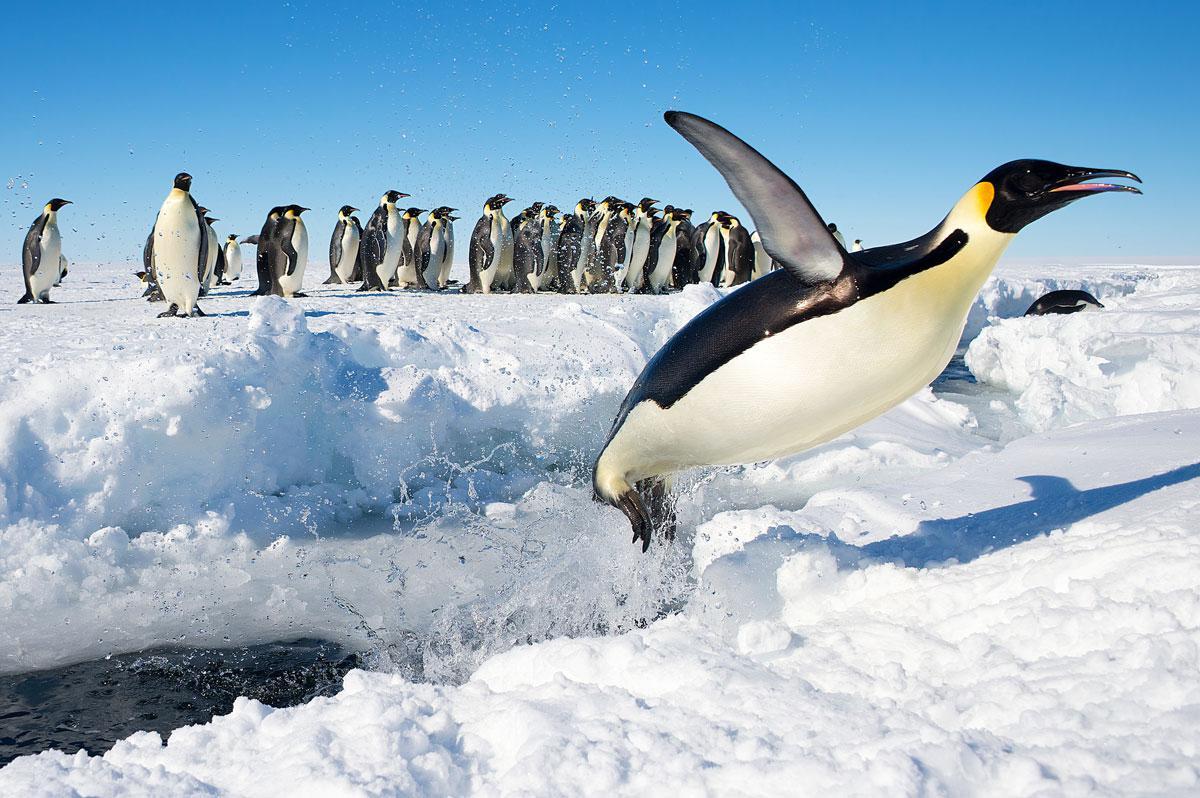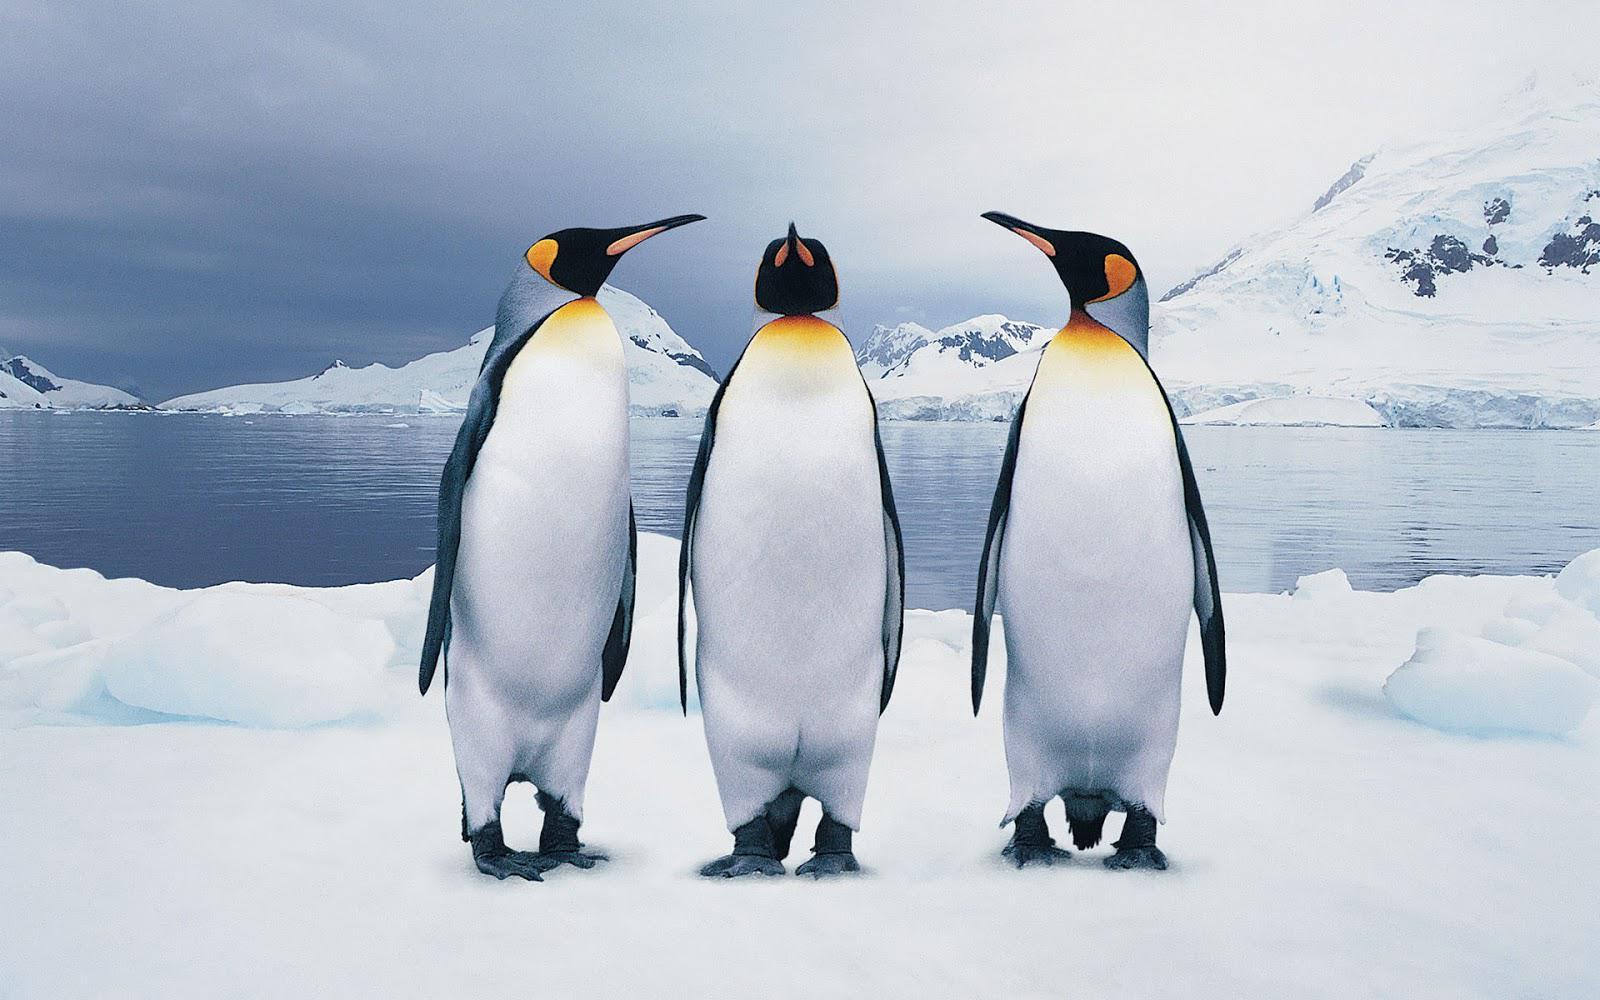The first image is the image on the left, the second image is the image on the right. Given the left and right images, does the statement "An image contains at least three penguins in the foreground, and all of them face in different directions." hold true? Answer yes or no. Yes. The first image is the image on the left, the second image is the image on the right. Considering the images on both sides, is "The right image contains no more than one penguin." valid? Answer yes or no. No. 